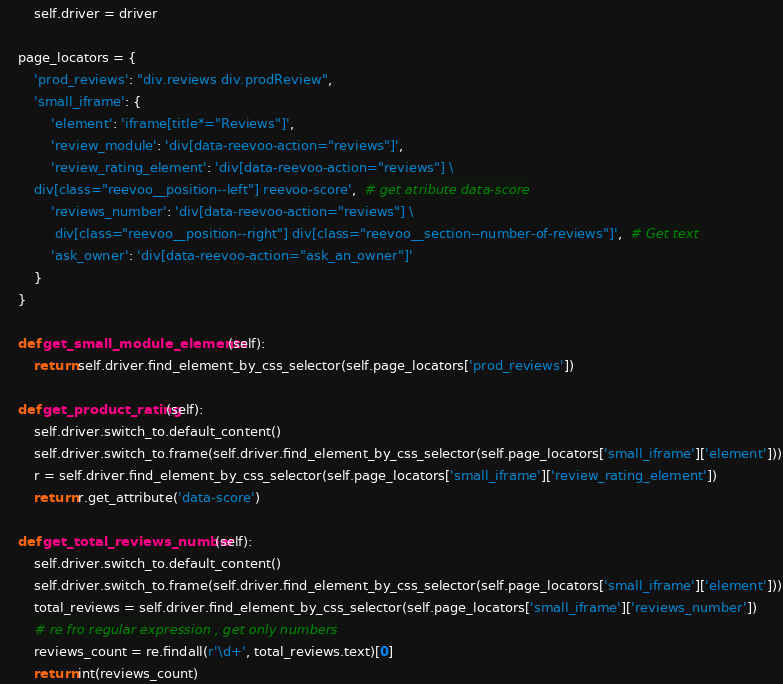<code> <loc_0><loc_0><loc_500><loc_500><_Python_>        self.driver = driver

    page_locators = {
        'prod_reviews': "div.reviews div.prodReview",
        'small_iframe': {
            'element': 'iframe[title*="Reviews"]',
            'review_module': 'div[data-reevoo-action="reviews"]',
            'review_rating_element': 'div[data-reevoo-action="reviews"] \
        div[class="reevoo__position--left"] reevoo-score',  # get atribute data-score
            'reviews_number': 'div[data-reevoo-action="reviews"] \
             div[class="reevoo__position--right"] div[class="reevoo__section--number-of-reviews"]',  # Get text
            'ask_owner': 'div[data-reevoo-action="ask_an_owner"]'
        }
    }

    def get_small_module_elements(self):
        return self.driver.find_element_by_css_selector(self.page_locators['prod_reviews'])

    def get_product_rating(self):
        self.driver.switch_to.default_content()
        self.driver.switch_to.frame(self.driver.find_element_by_css_selector(self.page_locators['small_iframe']['element']))
        r = self.driver.find_element_by_css_selector(self.page_locators['small_iframe']['review_rating_element'])
        return r.get_attribute('data-score')

    def get_total_reviews_number(self):
        self.driver.switch_to.default_content()
        self.driver.switch_to.frame(self.driver.find_element_by_css_selector(self.page_locators['small_iframe']['element']))
        total_reviews = self.driver.find_element_by_css_selector(self.page_locators['small_iframe']['reviews_number'])
        # re fro regular expression , get only numbers
        reviews_count = re.findall(r'\d+', total_reviews.text)[0]
        return int(reviews_count)
</code> 